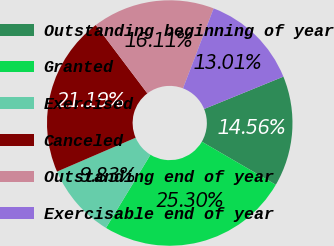Convert chart to OTSL. <chart><loc_0><loc_0><loc_500><loc_500><pie_chart><fcel>Outstanding beginning of year<fcel>Granted<fcel>Exercised<fcel>Canceled<fcel>Outstanding end of year<fcel>Exercisable end of year<nl><fcel>14.56%<fcel>25.3%<fcel>9.83%<fcel>21.19%<fcel>16.11%<fcel>13.01%<nl></chart> 